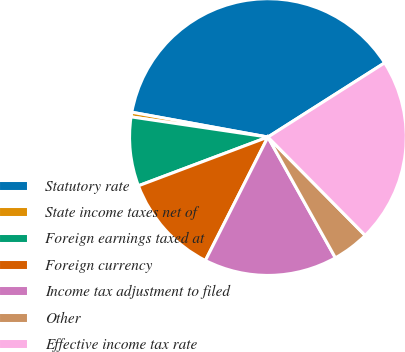Convert chart. <chart><loc_0><loc_0><loc_500><loc_500><pie_chart><fcel>Statutory rate<fcel>State income taxes net of<fcel>Foreign earnings taxed at<fcel>Foreign currency<fcel>Income tax adjustment to filed<fcel>Other<fcel>Effective income tax rate<nl><fcel>38.11%<fcel>0.54%<fcel>8.06%<fcel>11.81%<fcel>15.57%<fcel>4.3%<fcel>21.6%<nl></chart> 